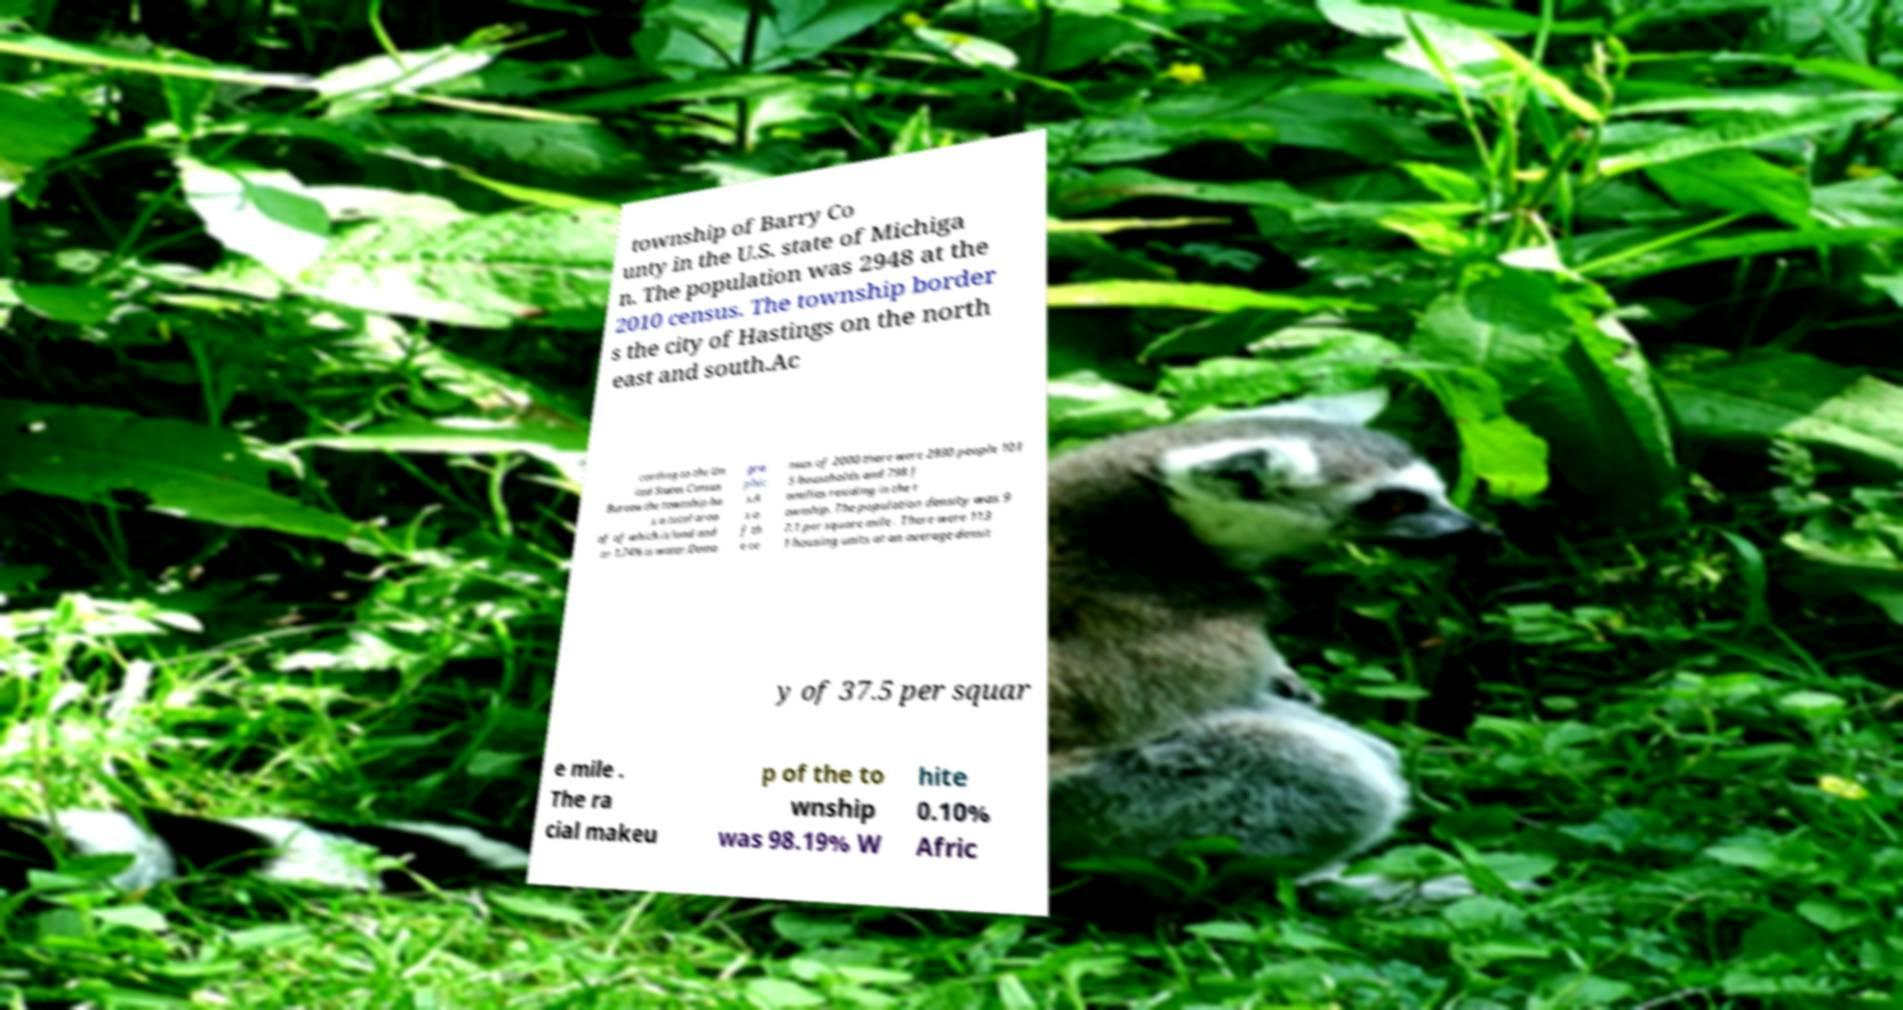Could you assist in decoding the text presented in this image and type it out clearly? township of Barry Co unty in the U.S. state of Michiga n. The population was 2948 at the 2010 census. The township border s the city of Hastings on the north east and south.Ac cording to the Un ited States Census Bureau the township ha s a total area of of which is land and or 1.74% is water.Demo gra phic s.A s o f th e ce nsus of 2000 there were 2930 people 101 5 households and 798 f amilies residing in the t ownship. The population density was 9 7.1 per square mile . There were 113 1 housing units at an average densit y of 37.5 per squar e mile . The ra cial makeu p of the to wnship was 98.19% W hite 0.10% Afric 